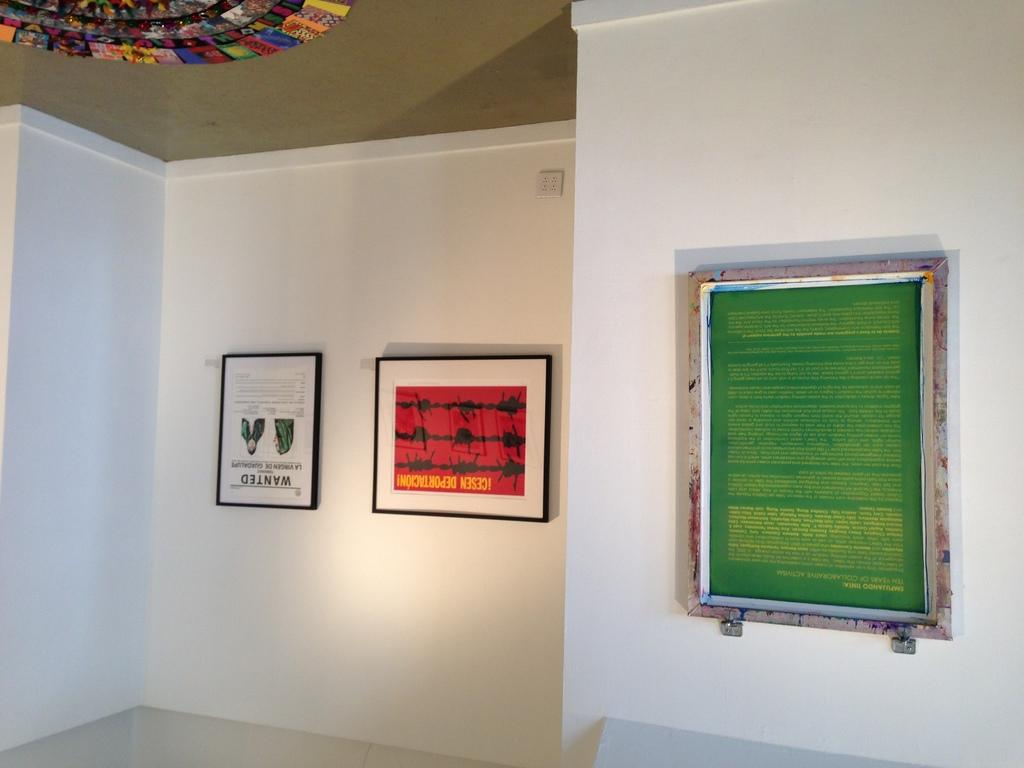How many photo frames are attached to the wall in the image? There are three photo frames attached to the wall in the image. Can you describe the object attached to the roof in the left top corner of the image? Unfortunately, the provided facts do not give any information about the object attached to the roof. What type of brass material is used in the photo frames in the image? The provided facts do not mention any brass material being used in the photo frames. Can you describe the acoustics of the room in the image? The provided facts do not give any information about the acoustics of the room in the image. 